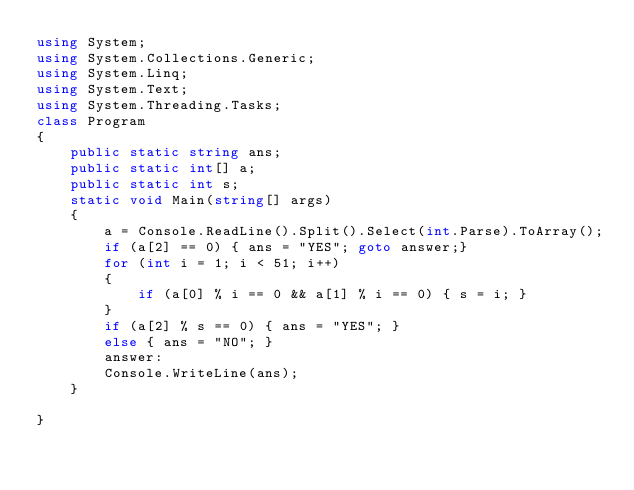Convert code to text. <code><loc_0><loc_0><loc_500><loc_500><_C#_>using System;
using System.Collections.Generic;
using System.Linq;
using System.Text;
using System.Threading.Tasks;
class Program
{
    public static string ans;
    public static int[] a;
    public static int s;
    static void Main(string[] args)
    {
        a = Console.ReadLine().Split().Select(int.Parse).ToArray();
        if (a[2] == 0) { ans = "YES"; goto answer;}
        for (int i = 1; i < 51; i++)
        {
            if (a[0] % i == 0 && a[1] % i == 0) { s = i; }
        }
        if (a[2] % s == 0) { ans = "YES"; }
        else { ans = "NO"; }
        answer:
        Console.WriteLine(ans);
    }
    
}
</code> 